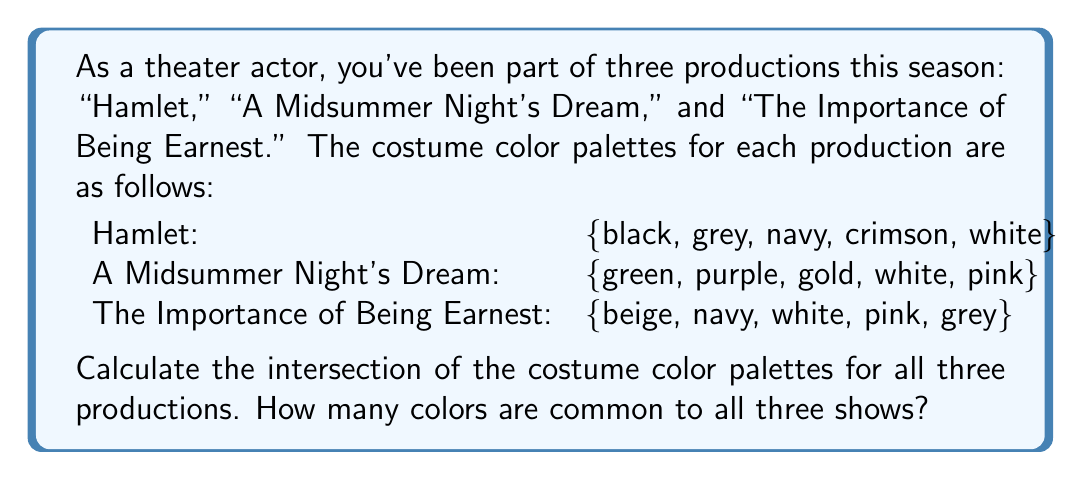Provide a solution to this math problem. To solve this problem, we need to find the intersection of the three sets representing the costume color palettes for each production. Let's define our sets:

$$H = \{black, grey, navy, crimson, white\}$$
$$M = \{green, purple, gold, white, pink\}$$
$$E = \{beige, navy, white, pink, grey\}$$

The intersection of these three sets, denoted as $H \cap M \cap E$, will give us the colors that are common to all three productions.

To find this intersection, we can:

1. Identify colors that appear in all three sets.
2. Count the number of these common colors.

Looking at the sets, we can see that:

- "white" appears in all three sets
- No other color appears in all three sets

Therefore, the intersection of the three sets is:

$$H \cap M \cap E = \{white\}$$

The number of elements in this intersection is 1.
Answer: The intersection of the costume color palettes for all three productions contains 1 color: white. 